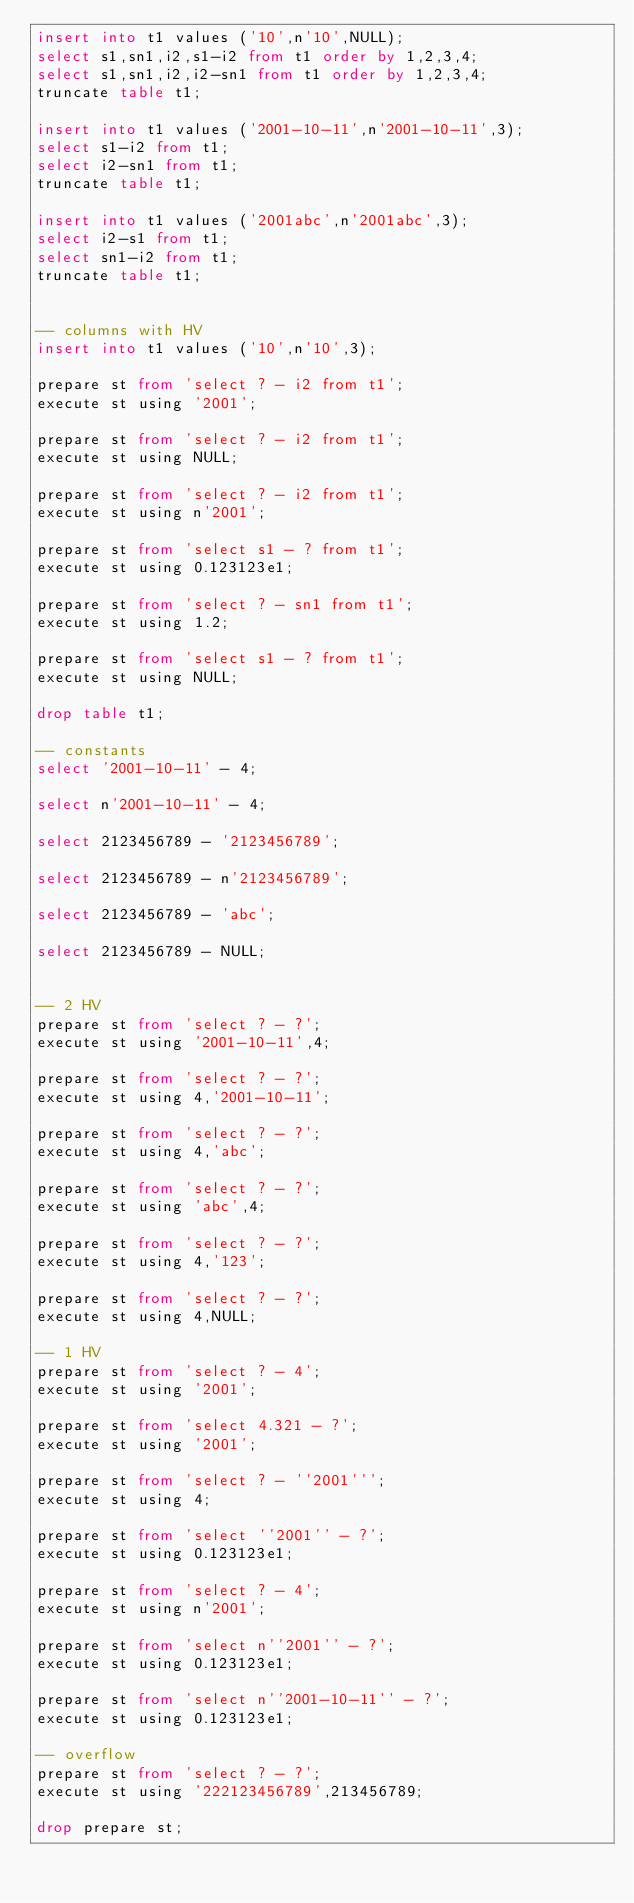Convert code to text. <code><loc_0><loc_0><loc_500><loc_500><_SQL_>insert into t1 values ('10',n'10',NULL);
select s1,sn1,i2,s1-i2 from t1 order by 1,2,3,4;
select s1,sn1,i2,i2-sn1 from t1 order by 1,2,3,4;
truncate table t1;

insert into t1 values ('2001-10-11',n'2001-10-11',3);
select s1-i2 from t1;
select i2-sn1 from t1;
truncate table t1;

insert into t1 values ('2001abc',n'2001abc',3);
select i2-s1 from t1;
select sn1-i2 from t1;
truncate table t1;


-- columns with HV
insert into t1 values ('10',n'10',3);

prepare st from 'select ? - i2 from t1';
execute st using '2001';

prepare st from 'select ? - i2 from t1';
execute st using NULL;

prepare st from 'select ? - i2 from t1';
execute st using n'2001';

prepare st from 'select s1 - ? from t1';
execute st using 0.123123e1;

prepare st from 'select ? - sn1 from t1';
execute st using 1.2;

prepare st from 'select s1 - ? from t1';
execute st using NULL;

drop table t1;

-- constants
select '2001-10-11' - 4;

select n'2001-10-11' - 4;

select 2123456789 - '2123456789';

select 2123456789 - n'2123456789';

select 2123456789 - 'abc';

select 2123456789 - NULL;


-- 2 HV
prepare st from 'select ? - ?';
execute st using '2001-10-11',4;

prepare st from 'select ? - ?';
execute st using 4,'2001-10-11';

prepare st from 'select ? - ?';
execute st using 4,'abc';

prepare st from 'select ? - ?';
execute st using 'abc',4;

prepare st from 'select ? - ?';
execute st using 4,'123';

prepare st from 'select ? - ?';
execute st using 4,NULL;

-- 1 HV
prepare st from 'select ? - 4';
execute st using '2001';

prepare st from 'select 4.321 - ?';
execute st using '2001';

prepare st from 'select ? - ''2001''';
execute st using 4;

prepare st from 'select ''2001'' - ?';
execute st using 0.123123e1;

prepare st from 'select ? - 4';
execute st using n'2001';

prepare st from 'select n''2001'' - ?';
execute st using 0.123123e1;

prepare st from 'select n''2001-10-11'' - ?';
execute st using 0.123123e1;

-- overflow
prepare st from 'select ? - ?';
execute st using '222123456789',213456789;

drop prepare st;
</code> 